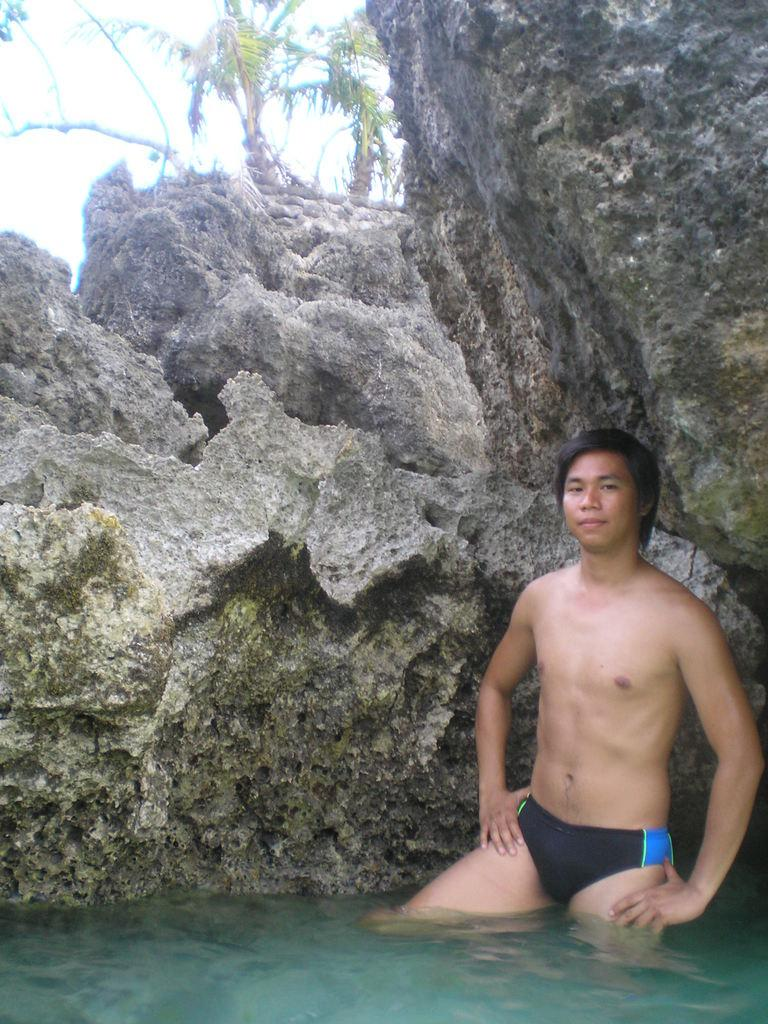What is the man in the image doing? The man is standing in the water on the right side of the image. What can be seen in the background of the image? There is a rock, trees, and the sky visible in the background of the image. What type of muscle can be seen flexing on the man's wrist in the image? There is no muscle visible on the man's wrist in the image, as the image does not show a close-up of his wrist. 